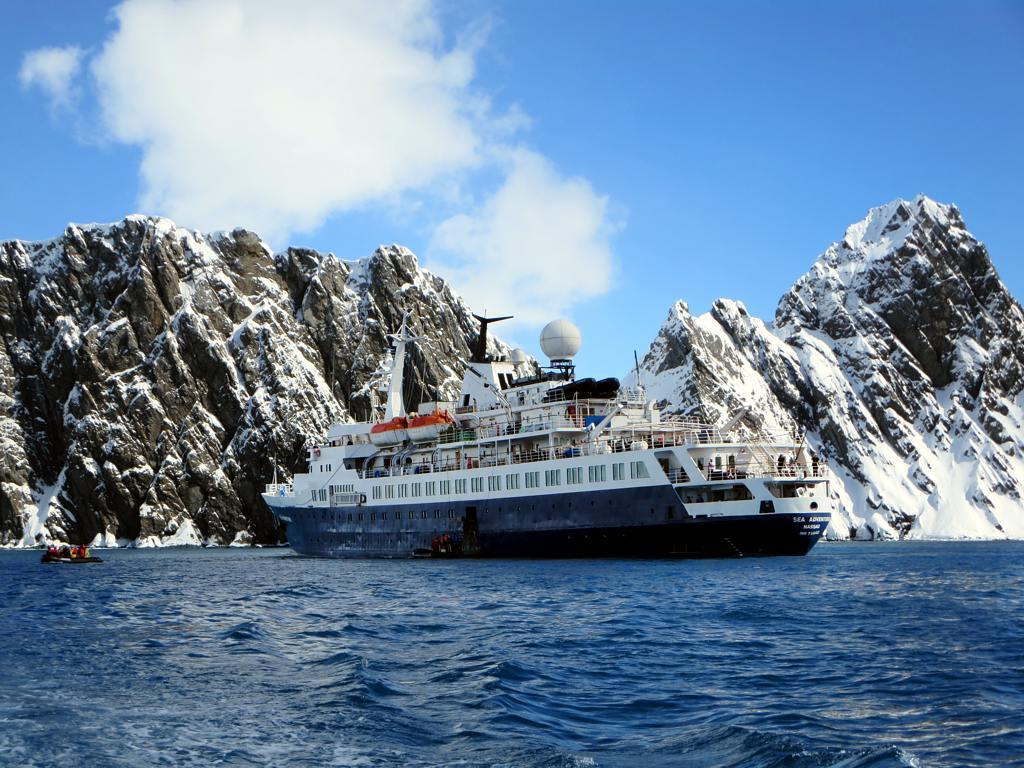What is at the bottom of the image? There is water at the bottom of the image. What is located above the water? There is a ship above the water. What can be seen behind the ship? There are hills visible behind the ship. What is the condition of the hills? There is snow on the hills. What is visible at the top of the image? There are clouds and the sky visible at the top of the image. How much value does the watch have in the image? There is no watch present in the image, so it is not possible to determine its value. What level of experience does the beginner have in the image? There is no reference to a beginner or any experience level in the image. 